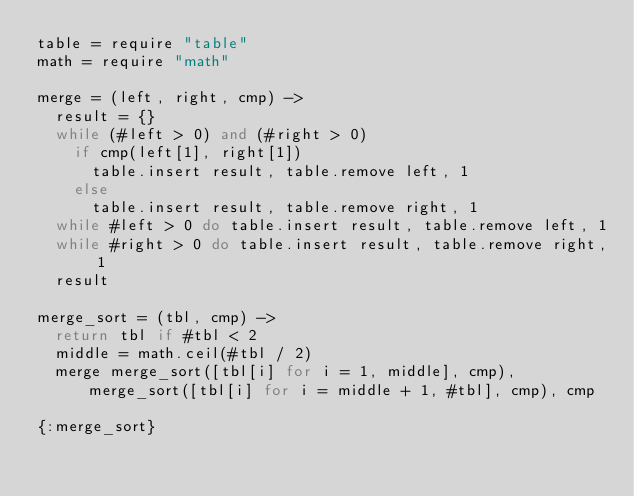Convert code to text. <code><loc_0><loc_0><loc_500><loc_500><_MoonScript_>table = require "table"
math = require "math"

merge = (left, right, cmp) ->
  result = {}
  while (#left > 0) and (#right > 0)
    if cmp(left[1], right[1])
      table.insert result, table.remove left, 1
    else
      table.insert result, table.remove right, 1
  while #left > 0 do table.insert result, table.remove left, 1
  while #right > 0 do table.insert result, table.remove right, 1
  result

merge_sort = (tbl, cmp) ->
  return tbl if #tbl < 2
  middle = math.ceil(#tbl / 2)
  merge merge_sort([tbl[i] for i = 1, middle], cmp), merge_sort([tbl[i] for i = middle + 1, #tbl], cmp), cmp

{:merge_sort}
</code> 